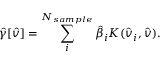Convert formula to latex. <formula><loc_0><loc_0><loc_500><loc_500>\hat { \gamma } [ \hat { v } ] = \sum _ { i } ^ { N _ { s a m p l e } } \hat { \beta } _ { i } K ( \hat { v } _ { i } , \hat { v } ) .</formula> 